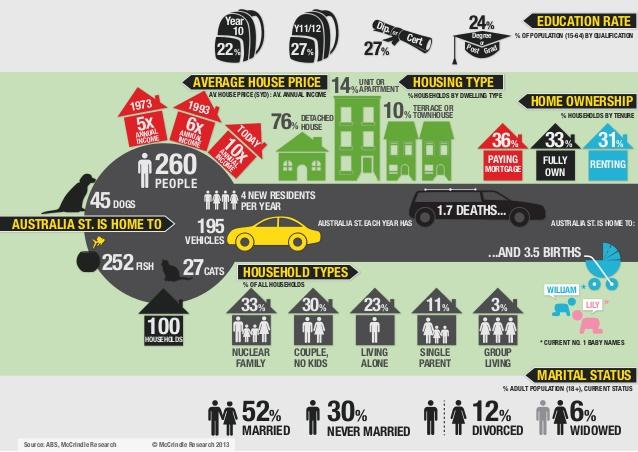Point out several critical features in this image. According to recent statistics, approximately 12% of the adult population in the United States has been divorced. The current most popular name for baby girls is Lily. The current top-ranking baby name for boys is William. Approximately 24% of housing types do not include detached houses. Group living households have the lowest percentage of all household types. 